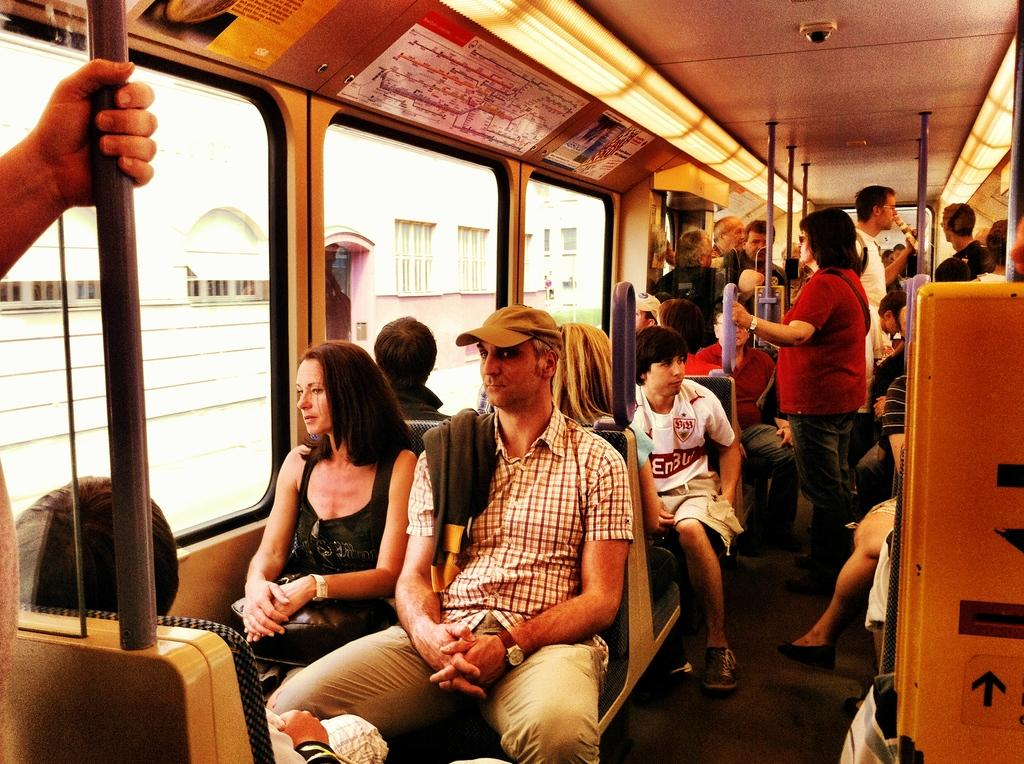What is the main subject in the foreground of the image? There is a crow in the foreground of the image. What is the crow doing in the image? The crow is sitting on seats in the image. What can be seen in the background of the image? There are people standing in a bus in the background of the image. Where does the image appear to be taken? The image appears to be taken inside a bus. What allows natural light to enter the bus in the image? There are windows visible in the image. What type of body language is the crow using to get the attention of the passengers in the image? There is no indication in the image that the crow is trying to get the attention of the passengers, and therefore no specific body language can be observed. 